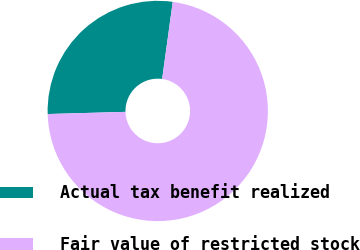Convert chart to OTSL. <chart><loc_0><loc_0><loc_500><loc_500><pie_chart><fcel>Actual tax benefit realized<fcel>Fair value of restricted stock<nl><fcel>27.62%<fcel>72.38%<nl></chart> 